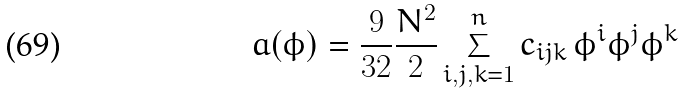<formula> <loc_0><loc_0><loc_500><loc_500>a ( \phi ) = \frac { 9 } { 3 2 } \frac { N ^ { 2 } } { 2 } \sum _ { i , j , k = 1 } ^ { n } c _ { i j k } \, \phi ^ { i } \phi ^ { j } \phi ^ { k }</formula> 